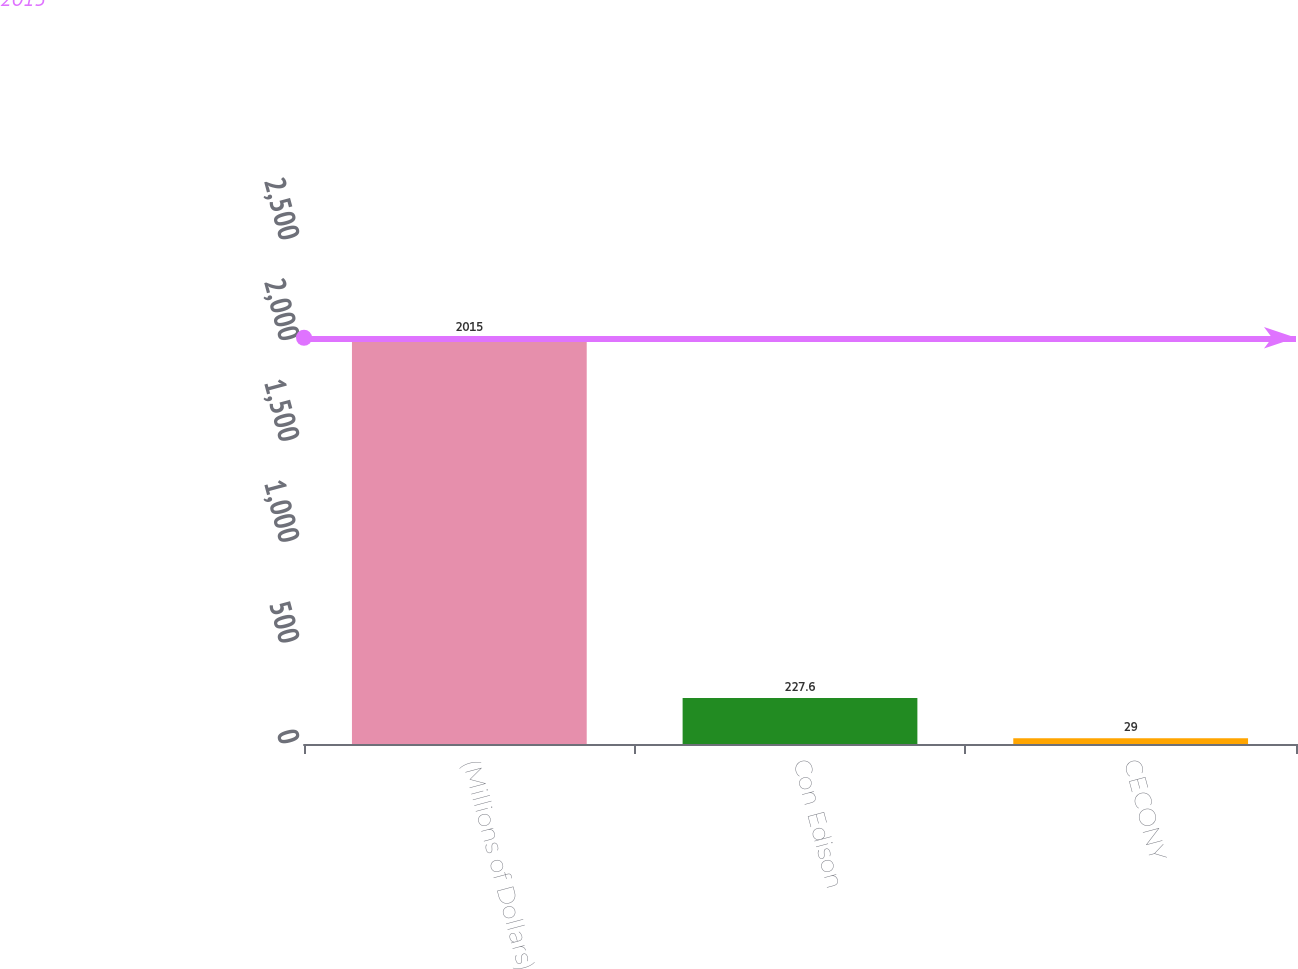<chart> <loc_0><loc_0><loc_500><loc_500><bar_chart><fcel>(Millions of Dollars)<fcel>Con Edison<fcel>CECONY<nl><fcel>2015<fcel>227.6<fcel>29<nl></chart> 